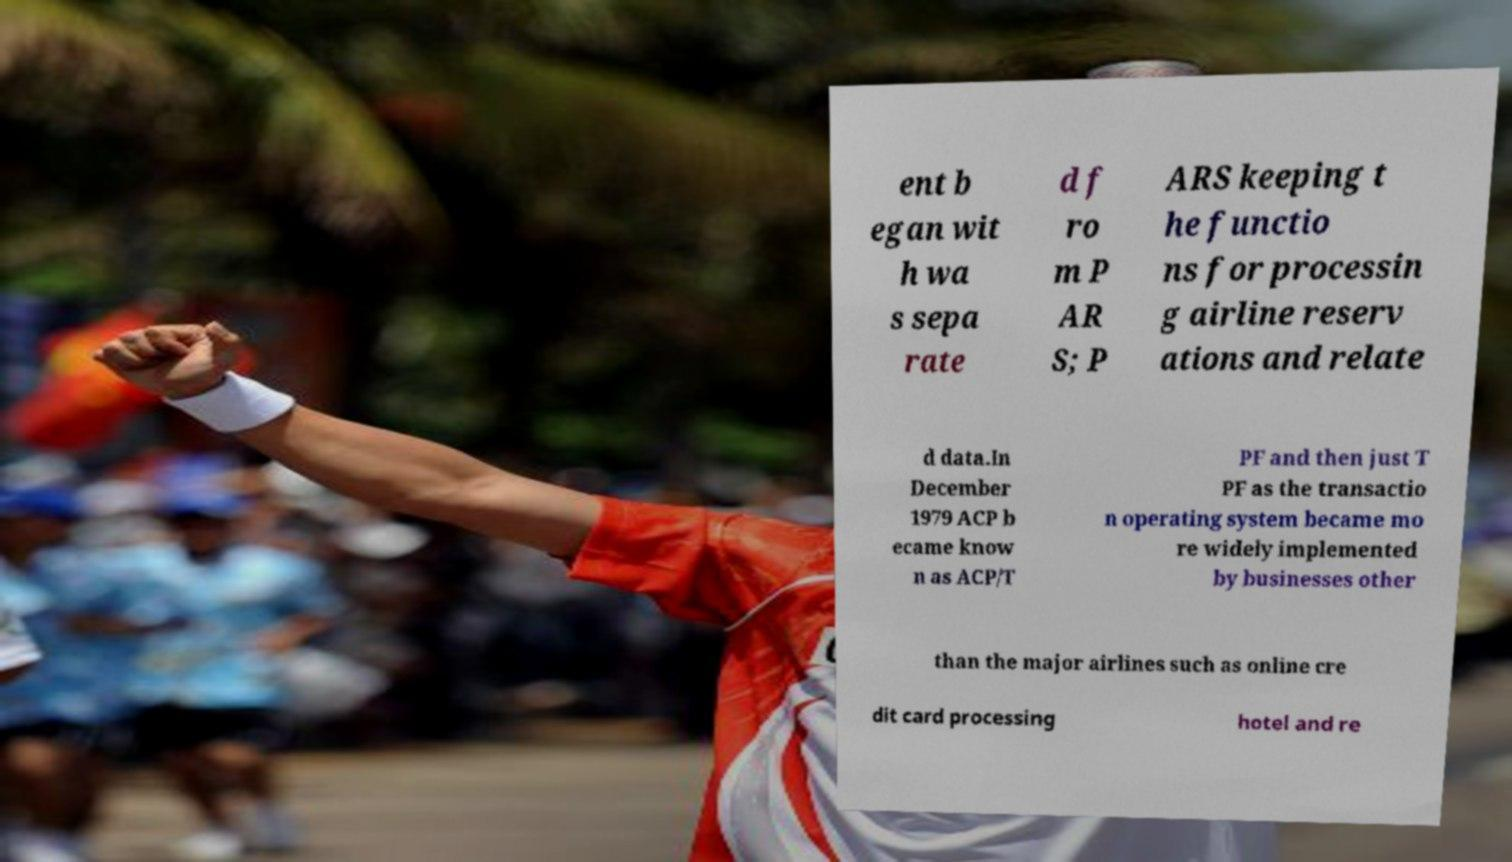Please read and relay the text visible in this image. What does it say? ent b egan wit h wa s sepa rate d f ro m P AR S; P ARS keeping t he functio ns for processin g airline reserv ations and relate d data.In December 1979 ACP b ecame know n as ACP/T PF and then just T PF as the transactio n operating system became mo re widely implemented by businesses other than the major airlines such as online cre dit card processing hotel and re 